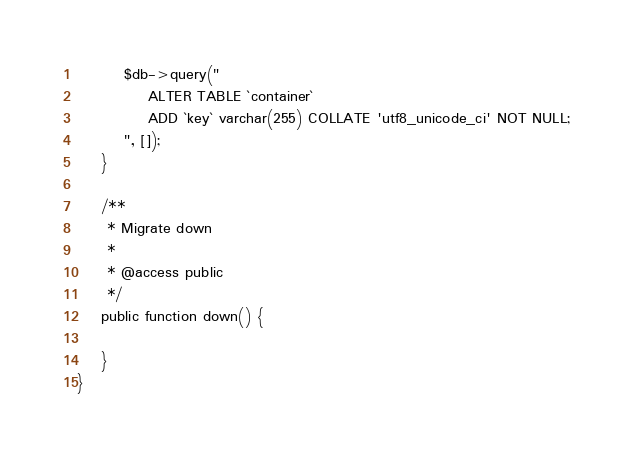<code> <loc_0><loc_0><loc_500><loc_500><_PHP_>
		$db->query("
			ALTER TABLE `container`
			ADD `key` varchar(255) COLLATE 'utf8_unicode_ci' NOT NULL;
		", []);
	}

	/**
	 * Migrate down
	 *
	 * @access public
	 */
	public function down() {

	}
}
</code> 